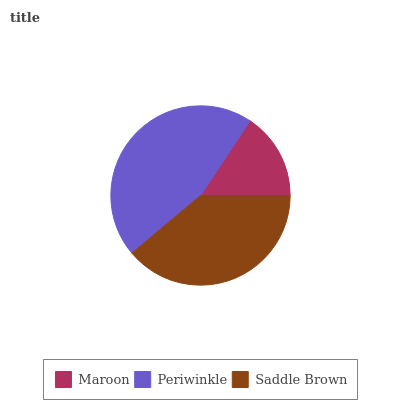Is Maroon the minimum?
Answer yes or no. Yes. Is Periwinkle the maximum?
Answer yes or no. Yes. Is Saddle Brown the minimum?
Answer yes or no. No. Is Saddle Brown the maximum?
Answer yes or no. No. Is Periwinkle greater than Saddle Brown?
Answer yes or no. Yes. Is Saddle Brown less than Periwinkle?
Answer yes or no. Yes. Is Saddle Brown greater than Periwinkle?
Answer yes or no. No. Is Periwinkle less than Saddle Brown?
Answer yes or no. No. Is Saddle Brown the high median?
Answer yes or no. Yes. Is Saddle Brown the low median?
Answer yes or no. Yes. Is Maroon the high median?
Answer yes or no. No. Is Periwinkle the low median?
Answer yes or no. No. 